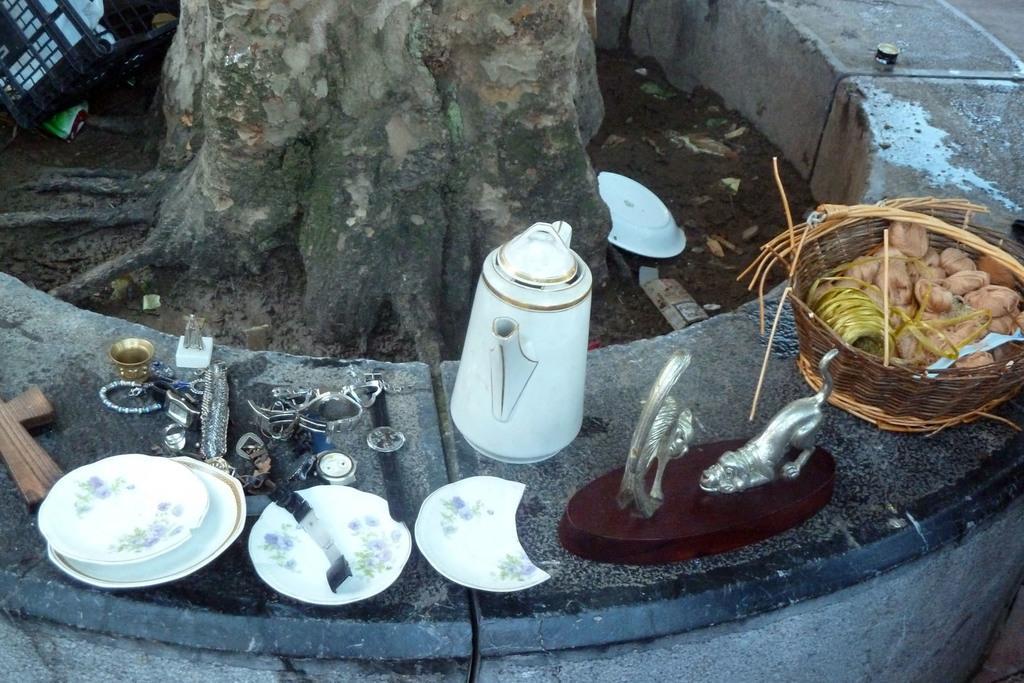Describe this image in one or two sentences. In this picture we can see a wall and on the wall there is a basket with some food items. On the left side of the wall there are jar, plate, sculptures and other objects. Behind the wall there is a tree trunk and on the path the is another plate and behind the basket there is a bottle lid. 